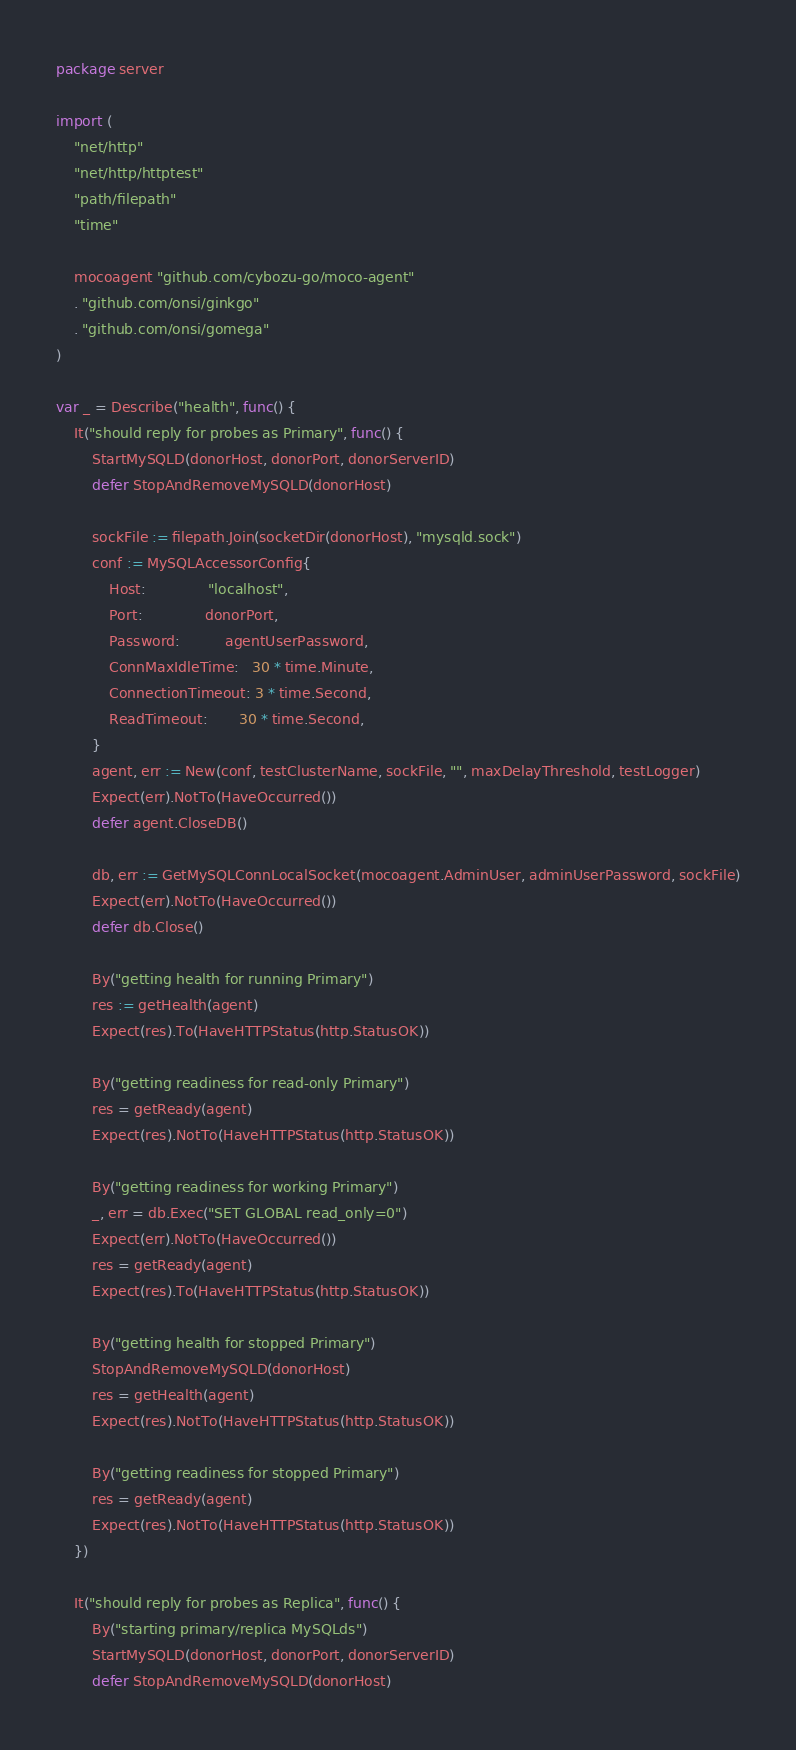<code> <loc_0><loc_0><loc_500><loc_500><_Go_>package server

import (
	"net/http"
	"net/http/httptest"
	"path/filepath"
	"time"

	mocoagent "github.com/cybozu-go/moco-agent"
	. "github.com/onsi/ginkgo"
	. "github.com/onsi/gomega"
)

var _ = Describe("health", func() {
	It("should reply for probes as Primary", func() {
		StartMySQLD(donorHost, donorPort, donorServerID)
		defer StopAndRemoveMySQLD(donorHost)

		sockFile := filepath.Join(socketDir(donorHost), "mysqld.sock")
		conf := MySQLAccessorConfig{
			Host:              "localhost",
			Port:              donorPort,
			Password:          agentUserPassword,
			ConnMaxIdleTime:   30 * time.Minute,
			ConnectionTimeout: 3 * time.Second,
			ReadTimeout:       30 * time.Second,
		}
		agent, err := New(conf, testClusterName, sockFile, "", maxDelayThreshold, testLogger)
		Expect(err).NotTo(HaveOccurred())
		defer agent.CloseDB()

		db, err := GetMySQLConnLocalSocket(mocoagent.AdminUser, adminUserPassword, sockFile)
		Expect(err).NotTo(HaveOccurred())
		defer db.Close()

		By("getting health for running Primary")
		res := getHealth(agent)
		Expect(res).To(HaveHTTPStatus(http.StatusOK))

		By("getting readiness for read-only Primary")
		res = getReady(agent)
		Expect(res).NotTo(HaveHTTPStatus(http.StatusOK))

		By("getting readiness for working Primary")
		_, err = db.Exec("SET GLOBAL read_only=0")
		Expect(err).NotTo(HaveOccurred())
		res = getReady(agent)
		Expect(res).To(HaveHTTPStatus(http.StatusOK))

		By("getting health for stopped Primary")
		StopAndRemoveMySQLD(donorHost)
		res = getHealth(agent)
		Expect(res).NotTo(HaveHTTPStatus(http.StatusOK))

		By("getting readiness for stopped Primary")
		res = getReady(agent)
		Expect(res).NotTo(HaveHTTPStatus(http.StatusOK))
	})

	It("should reply for probes as Replica", func() {
		By("starting primary/replica MySQLds")
		StartMySQLD(donorHost, donorPort, donorServerID)
		defer StopAndRemoveMySQLD(donorHost)
</code> 